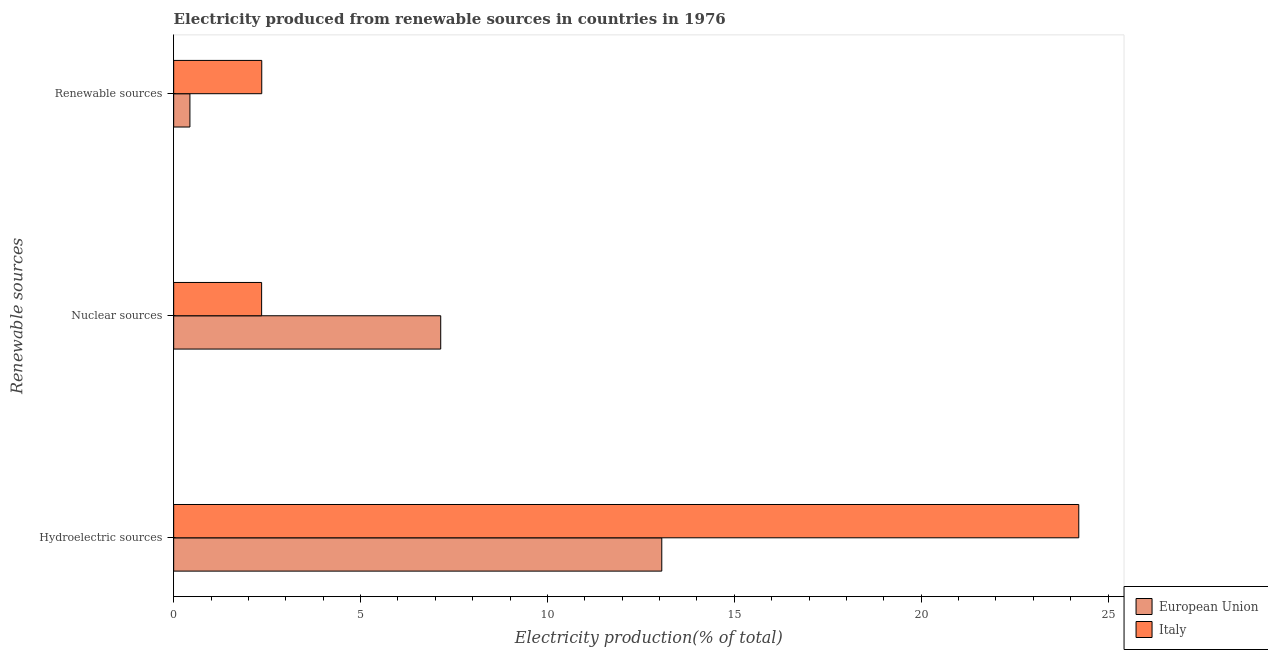How many groups of bars are there?
Offer a very short reply. 3. Are the number of bars per tick equal to the number of legend labels?
Provide a succinct answer. Yes. Are the number of bars on each tick of the Y-axis equal?
Offer a terse response. Yes. What is the label of the 3rd group of bars from the top?
Offer a very short reply. Hydroelectric sources. What is the percentage of electricity produced by hydroelectric sources in Italy?
Ensure brevity in your answer.  24.22. Across all countries, what is the maximum percentage of electricity produced by nuclear sources?
Ensure brevity in your answer.  7.14. Across all countries, what is the minimum percentage of electricity produced by renewable sources?
Provide a succinct answer. 0.43. In which country was the percentage of electricity produced by hydroelectric sources maximum?
Offer a very short reply. Italy. In which country was the percentage of electricity produced by renewable sources minimum?
Offer a very short reply. European Union. What is the total percentage of electricity produced by nuclear sources in the graph?
Your answer should be very brief. 9.5. What is the difference between the percentage of electricity produced by nuclear sources in European Union and that in Italy?
Your answer should be compact. 4.79. What is the difference between the percentage of electricity produced by renewable sources in European Union and the percentage of electricity produced by nuclear sources in Italy?
Provide a succinct answer. -1.92. What is the average percentage of electricity produced by nuclear sources per country?
Make the answer very short. 4.75. What is the difference between the percentage of electricity produced by renewable sources and percentage of electricity produced by nuclear sources in Italy?
Give a very brief answer. 0. What is the ratio of the percentage of electricity produced by hydroelectric sources in Italy to that in European Union?
Provide a short and direct response. 1.85. Is the percentage of electricity produced by hydroelectric sources in European Union less than that in Italy?
Give a very brief answer. Yes. What is the difference between the highest and the second highest percentage of electricity produced by renewable sources?
Your response must be concise. 1.92. What is the difference between the highest and the lowest percentage of electricity produced by nuclear sources?
Offer a terse response. 4.79. In how many countries, is the percentage of electricity produced by renewable sources greater than the average percentage of electricity produced by renewable sources taken over all countries?
Provide a short and direct response. 1. Is the sum of the percentage of electricity produced by renewable sources in Italy and European Union greater than the maximum percentage of electricity produced by nuclear sources across all countries?
Give a very brief answer. No. What does the 1st bar from the top in Renewable sources represents?
Give a very brief answer. Italy. Is it the case that in every country, the sum of the percentage of electricity produced by hydroelectric sources and percentage of electricity produced by nuclear sources is greater than the percentage of electricity produced by renewable sources?
Your response must be concise. Yes. Are all the bars in the graph horizontal?
Your answer should be compact. Yes. Are the values on the major ticks of X-axis written in scientific E-notation?
Make the answer very short. No. Does the graph contain grids?
Provide a succinct answer. No. Where does the legend appear in the graph?
Your answer should be very brief. Bottom right. How many legend labels are there?
Provide a succinct answer. 2. What is the title of the graph?
Offer a terse response. Electricity produced from renewable sources in countries in 1976. Does "Samoa" appear as one of the legend labels in the graph?
Make the answer very short. No. What is the label or title of the Y-axis?
Offer a terse response. Renewable sources. What is the Electricity production(% of total) in European Union in Hydroelectric sources?
Provide a succinct answer. 13.06. What is the Electricity production(% of total) of Italy in Hydroelectric sources?
Offer a terse response. 24.22. What is the Electricity production(% of total) in European Union in Nuclear sources?
Offer a very short reply. 7.14. What is the Electricity production(% of total) of Italy in Nuclear sources?
Make the answer very short. 2.35. What is the Electricity production(% of total) of European Union in Renewable sources?
Your response must be concise. 0.43. What is the Electricity production(% of total) in Italy in Renewable sources?
Your response must be concise. 2.36. Across all Renewable sources, what is the maximum Electricity production(% of total) of European Union?
Your answer should be very brief. 13.06. Across all Renewable sources, what is the maximum Electricity production(% of total) in Italy?
Your answer should be compact. 24.22. Across all Renewable sources, what is the minimum Electricity production(% of total) of European Union?
Make the answer very short. 0.43. Across all Renewable sources, what is the minimum Electricity production(% of total) of Italy?
Keep it short and to the point. 2.35. What is the total Electricity production(% of total) in European Union in the graph?
Provide a succinct answer. 20.64. What is the total Electricity production(% of total) of Italy in the graph?
Give a very brief answer. 28.92. What is the difference between the Electricity production(% of total) of European Union in Hydroelectric sources and that in Nuclear sources?
Give a very brief answer. 5.91. What is the difference between the Electricity production(% of total) of Italy in Hydroelectric sources and that in Nuclear sources?
Ensure brevity in your answer.  21.86. What is the difference between the Electricity production(% of total) of European Union in Hydroelectric sources and that in Renewable sources?
Give a very brief answer. 12.62. What is the difference between the Electricity production(% of total) of Italy in Hydroelectric sources and that in Renewable sources?
Provide a short and direct response. 21.86. What is the difference between the Electricity production(% of total) of European Union in Nuclear sources and that in Renewable sources?
Ensure brevity in your answer.  6.71. What is the difference between the Electricity production(% of total) in Italy in Nuclear sources and that in Renewable sources?
Your answer should be compact. -0. What is the difference between the Electricity production(% of total) of European Union in Hydroelectric sources and the Electricity production(% of total) of Italy in Nuclear sources?
Ensure brevity in your answer.  10.71. What is the difference between the Electricity production(% of total) of European Union in Hydroelectric sources and the Electricity production(% of total) of Italy in Renewable sources?
Your answer should be compact. 10.7. What is the difference between the Electricity production(% of total) of European Union in Nuclear sources and the Electricity production(% of total) of Italy in Renewable sources?
Offer a terse response. 4.79. What is the average Electricity production(% of total) in European Union per Renewable sources?
Provide a short and direct response. 6.88. What is the average Electricity production(% of total) of Italy per Renewable sources?
Ensure brevity in your answer.  9.64. What is the difference between the Electricity production(% of total) of European Union and Electricity production(% of total) of Italy in Hydroelectric sources?
Give a very brief answer. -11.16. What is the difference between the Electricity production(% of total) in European Union and Electricity production(% of total) in Italy in Nuclear sources?
Ensure brevity in your answer.  4.79. What is the difference between the Electricity production(% of total) in European Union and Electricity production(% of total) in Italy in Renewable sources?
Your answer should be compact. -1.92. What is the ratio of the Electricity production(% of total) of European Union in Hydroelectric sources to that in Nuclear sources?
Keep it short and to the point. 1.83. What is the ratio of the Electricity production(% of total) of Italy in Hydroelectric sources to that in Nuclear sources?
Offer a very short reply. 10.29. What is the ratio of the Electricity production(% of total) of European Union in Hydroelectric sources to that in Renewable sources?
Ensure brevity in your answer.  30.05. What is the ratio of the Electricity production(% of total) of Italy in Hydroelectric sources to that in Renewable sources?
Your answer should be compact. 10.28. What is the ratio of the Electricity production(% of total) in European Union in Nuclear sources to that in Renewable sources?
Keep it short and to the point. 16.44. What is the difference between the highest and the second highest Electricity production(% of total) in European Union?
Provide a short and direct response. 5.91. What is the difference between the highest and the second highest Electricity production(% of total) of Italy?
Provide a short and direct response. 21.86. What is the difference between the highest and the lowest Electricity production(% of total) of European Union?
Ensure brevity in your answer.  12.62. What is the difference between the highest and the lowest Electricity production(% of total) of Italy?
Keep it short and to the point. 21.86. 